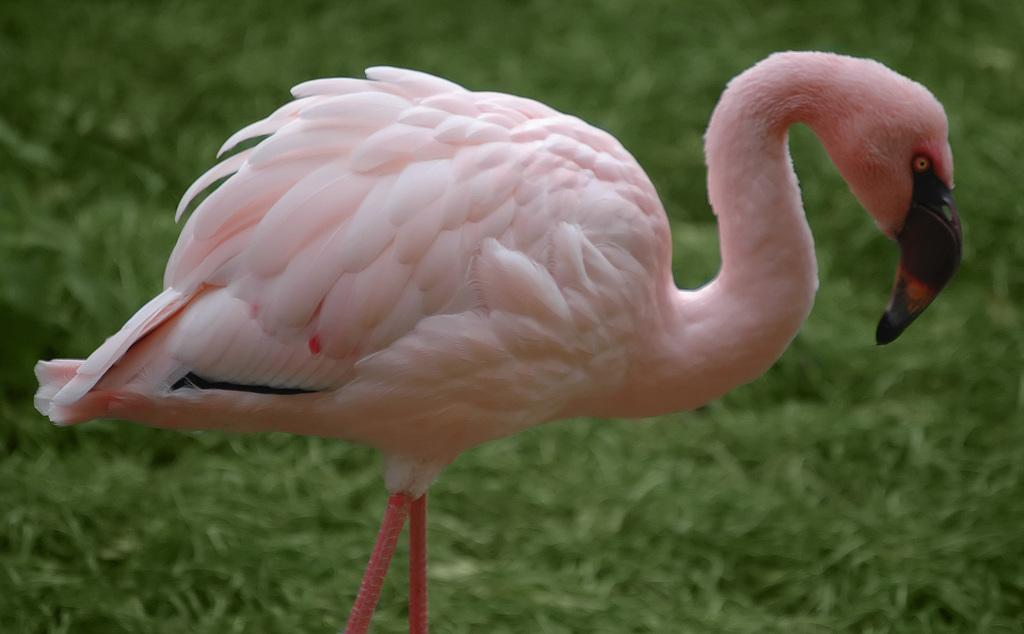What type of animal is in the image? There is a flamingo in the image. What can be seen in the background of the image? There is grass in the background of the image. How many seats are available for the expert to sit on in the image? There are no seats or experts present in the image; it features a flamingo and grass in the background. 